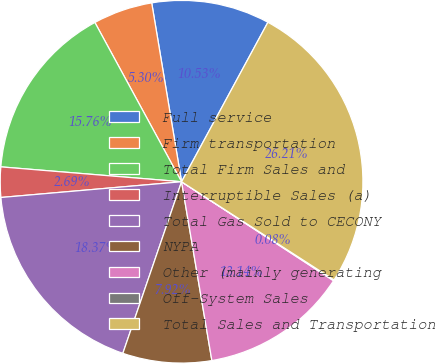<chart> <loc_0><loc_0><loc_500><loc_500><pie_chart><fcel>Full service<fcel>Firm transportation<fcel>Total Firm Sales and<fcel>Interruptible Sales (a)<fcel>Total Gas Sold to CECONY<fcel>NYPA<fcel>Other (mainly generating<fcel>Off-System Sales<fcel>Total Sales and Transportation<nl><fcel>10.53%<fcel>5.3%<fcel>15.76%<fcel>2.69%<fcel>18.37%<fcel>7.92%<fcel>13.14%<fcel>0.08%<fcel>26.21%<nl></chart> 